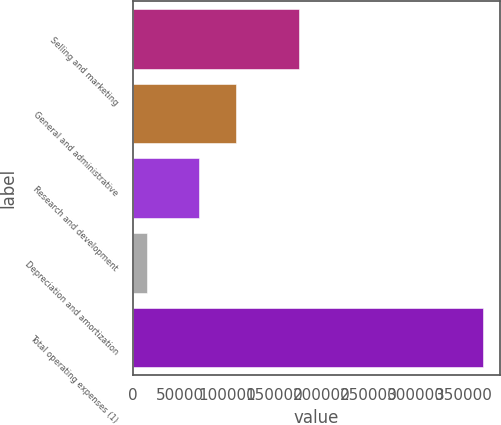Convert chart to OTSL. <chart><loc_0><loc_0><loc_500><loc_500><bar_chart><fcel>Selling and marketing<fcel>General and administrative<fcel>Research and development<fcel>Depreciation and amortization<fcel>Total operating expenses (1)<nl><fcel>176294<fcel>109484<fcel>69576<fcel>14999<fcel>370353<nl></chart> 